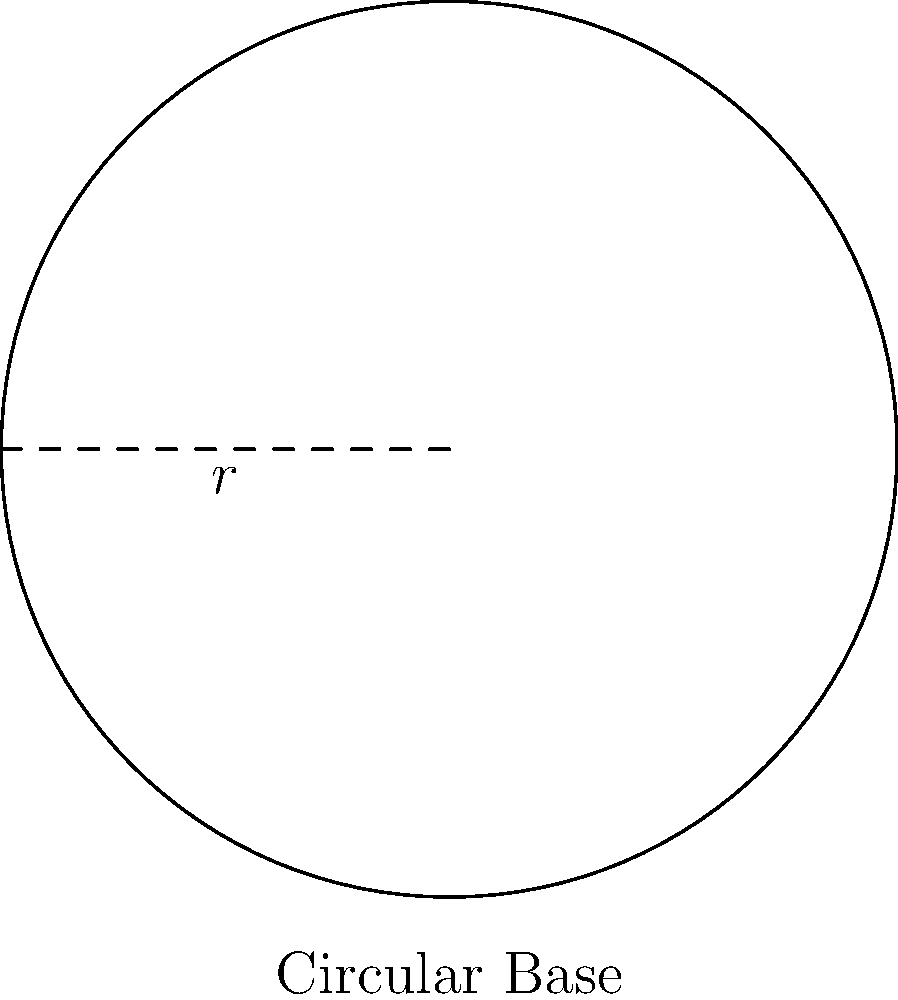A circular knitting machine at Međimurska trikotaža Čakovec has a base with a radius of 1.5 meters. What is the area of the machine's base in square meters? To find the area of the circular base, we need to use the formula for the area of a circle:

$$A = \pi r^2$$

Where:
$A$ is the area
$\pi$ (pi) is approximately 3.14159
$r$ is the radius of the circle

Given:
Radius $(r) = 1.5$ meters

Let's calculate the area:

$$\begin{align}
A &= \pi r^2 \\
&= \pi \times (1.5)^2 \\
&= \pi \times 2.25 \\
&\approx 3.14159 \times 2.25 \\
&\approx 7.0686 \text{ square meters}
\end{align}$$

Rounding to two decimal places:
$$A \approx 7.07 \text{ square meters}$$
Answer: 7.07 m² 